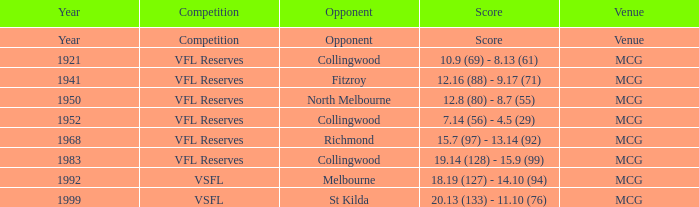5 (29)? MCG. 